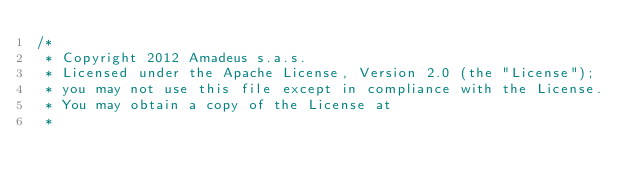Convert code to text. <code><loc_0><loc_0><loc_500><loc_500><_JavaScript_>/*
 * Copyright 2012 Amadeus s.a.s.
 * Licensed under the Apache License, Version 2.0 (the "License");
 * you may not use this file except in compliance with the License.
 * You may obtain a copy of the License at
 *</code> 